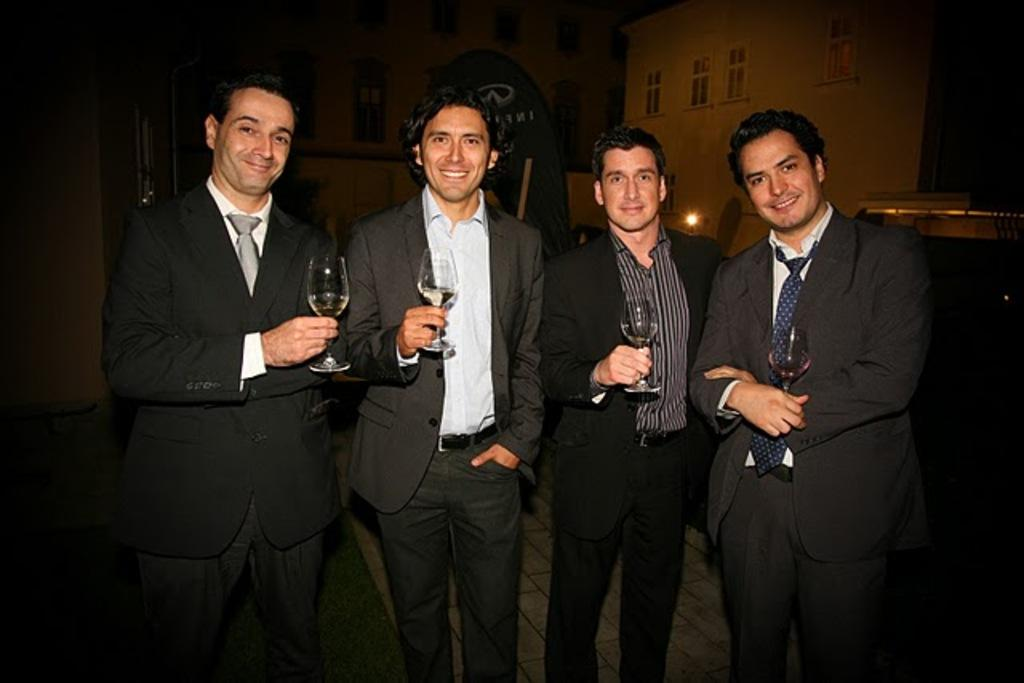How many persons are in the image? There are persons in the image. What objects are visible in the image that people might use? There are glasses visible in the image. What can be seen in the distance in the image? There are buildings in the background of the image. What type of light is visible in the background of the image? There is light visible in the background of the image. What else can be seen in the background of the image? There are other objects present in the background of the image. What type of boot is visible in the image? There is no boot present in the image. 